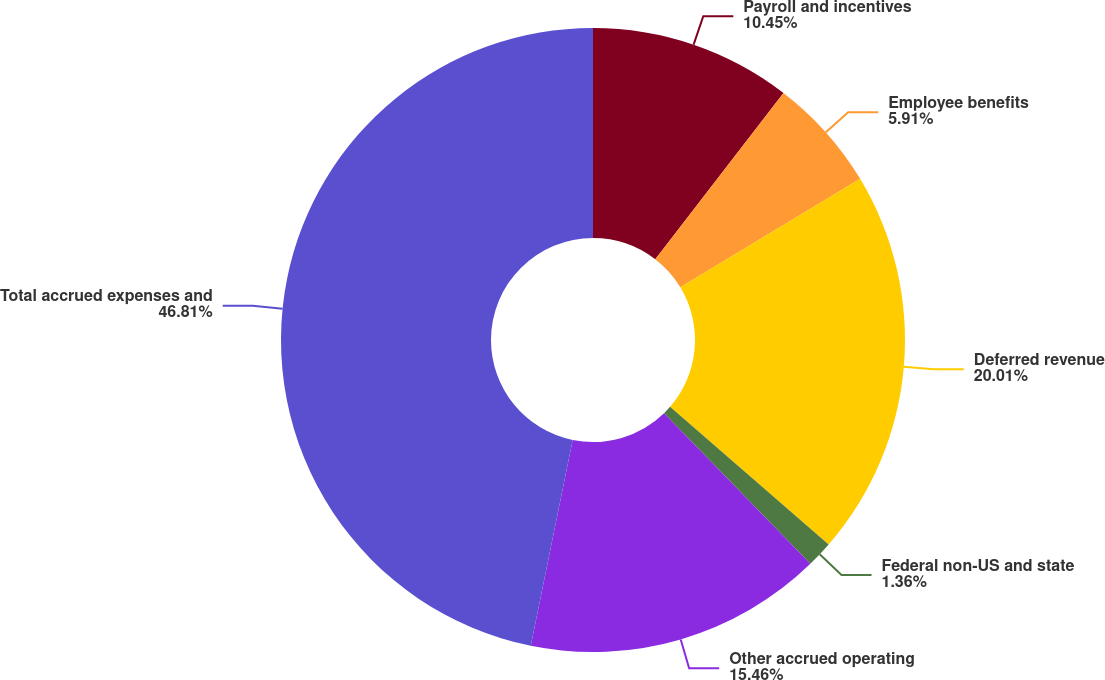<chart> <loc_0><loc_0><loc_500><loc_500><pie_chart><fcel>Payroll and incentives<fcel>Employee benefits<fcel>Deferred revenue<fcel>Federal non-US and state<fcel>Other accrued operating<fcel>Total accrued expenses and<nl><fcel>10.45%<fcel>5.91%<fcel>20.01%<fcel>1.36%<fcel>15.46%<fcel>46.8%<nl></chart> 